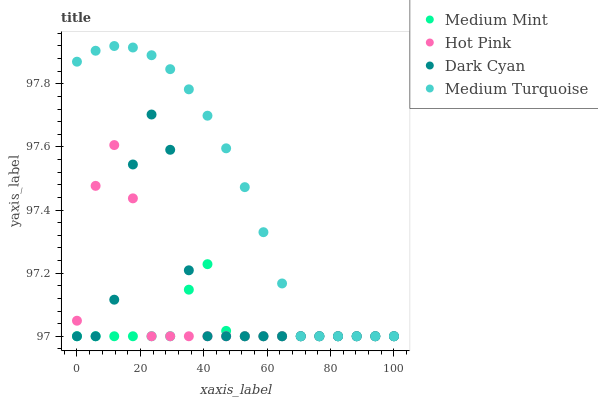Does Medium Mint have the minimum area under the curve?
Answer yes or no. Yes. Does Medium Turquoise have the maximum area under the curve?
Answer yes or no. Yes. Does Dark Cyan have the minimum area under the curve?
Answer yes or no. No. Does Dark Cyan have the maximum area under the curve?
Answer yes or no. No. Is Medium Turquoise the smoothest?
Answer yes or no. Yes. Is Dark Cyan the roughest?
Answer yes or no. Yes. Is Hot Pink the smoothest?
Answer yes or no. No. Is Hot Pink the roughest?
Answer yes or no. No. Does Medium Mint have the lowest value?
Answer yes or no. Yes. Does Medium Turquoise have the highest value?
Answer yes or no. Yes. Does Dark Cyan have the highest value?
Answer yes or no. No. Does Dark Cyan intersect Hot Pink?
Answer yes or no. Yes. Is Dark Cyan less than Hot Pink?
Answer yes or no. No. Is Dark Cyan greater than Hot Pink?
Answer yes or no. No. 